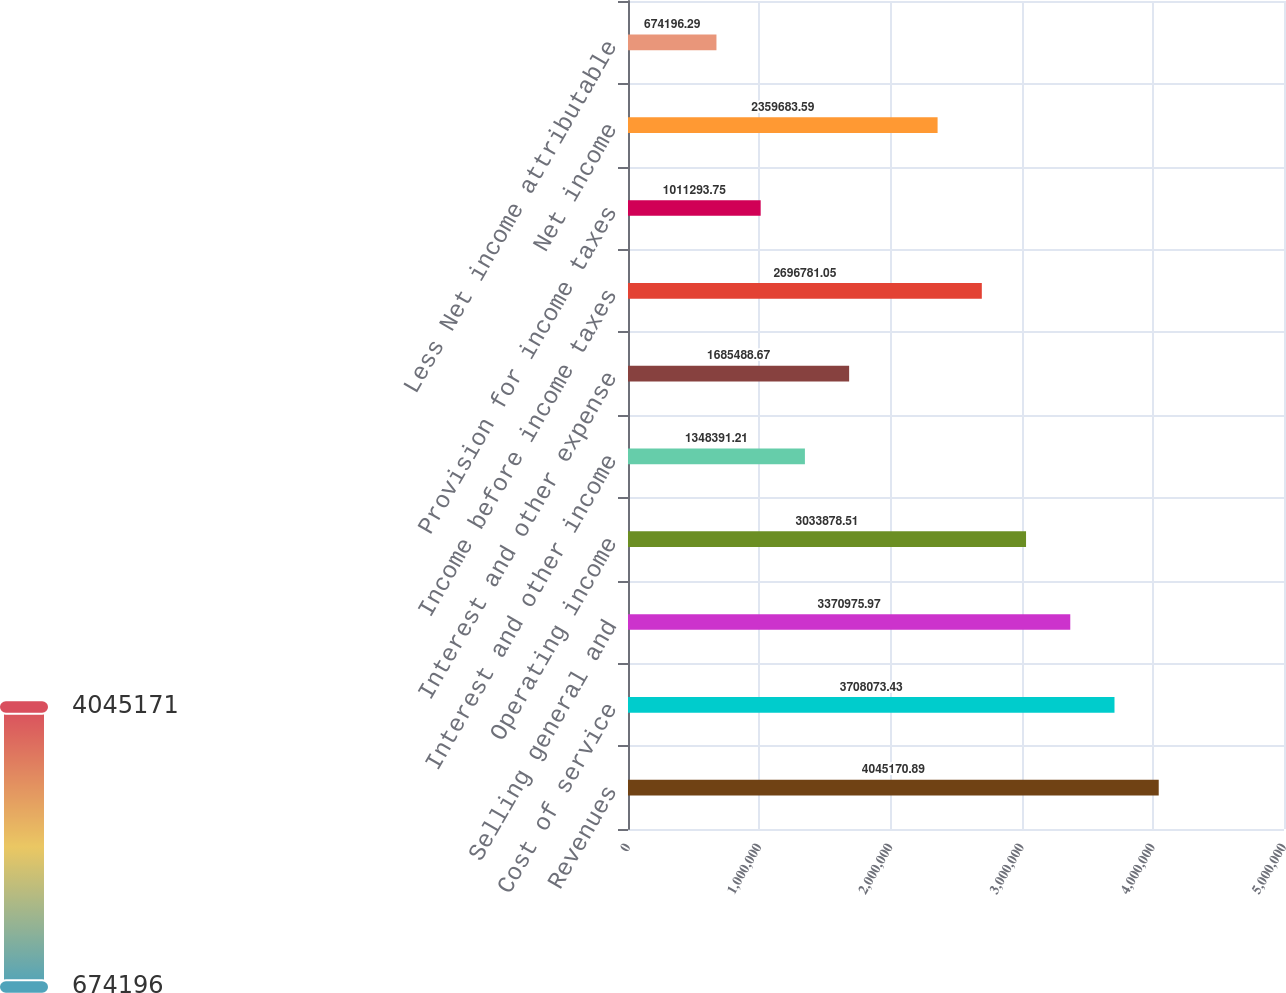<chart> <loc_0><loc_0><loc_500><loc_500><bar_chart><fcel>Revenues<fcel>Cost of service<fcel>Selling general and<fcel>Operating income<fcel>Interest and other income<fcel>Interest and other expense<fcel>Income before income taxes<fcel>Provision for income taxes<fcel>Net income<fcel>Less Net income attributable<nl><fcel>4.04517e+06<fcel>3.70807e+06<fcel>3.37098e+06<fcel>3.03388e+06<fcel>1.34839e+06<fcel>1.68549e+06<fcel>2.69678e+06<fcel>1.01129e+06<fcel>2.35968e+06<fcel>674196<nl></chart> 